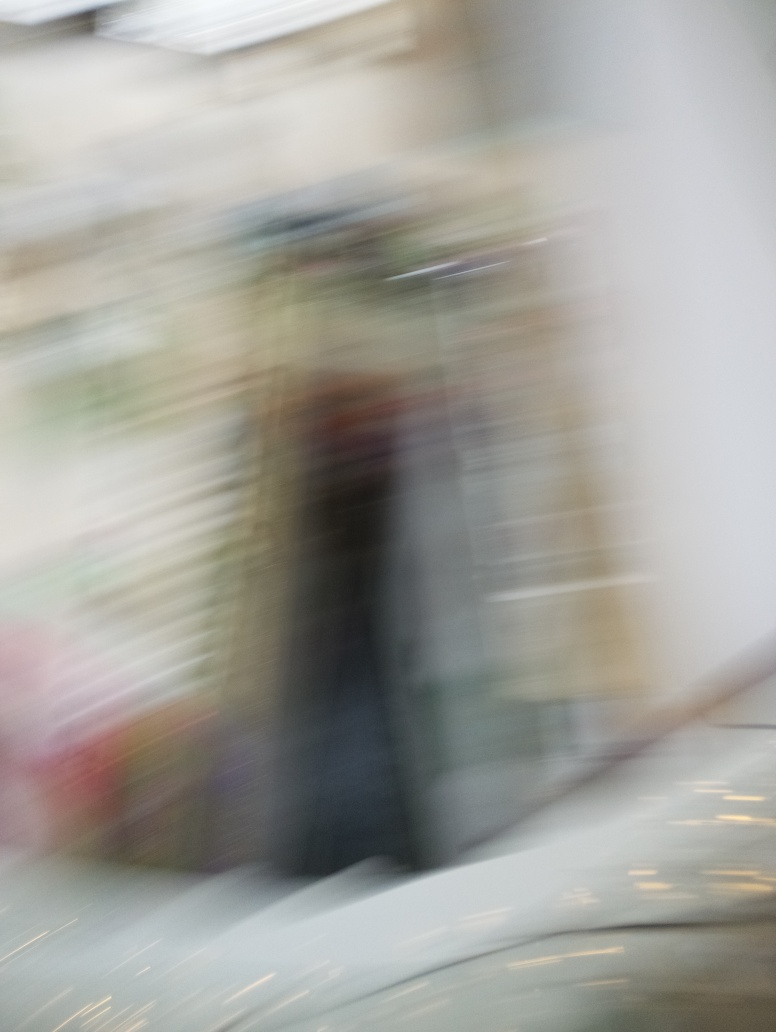What effect does ghosting have on the image? Option D, the loss of texture details, is correct. Ghosting refers to the appearance of a trail or blur in an image, often due to movement during the capture of the image or delayed pixel response times. This effect can reduce the sharpness and clarity, causing texture details to be obscured or less defined. 